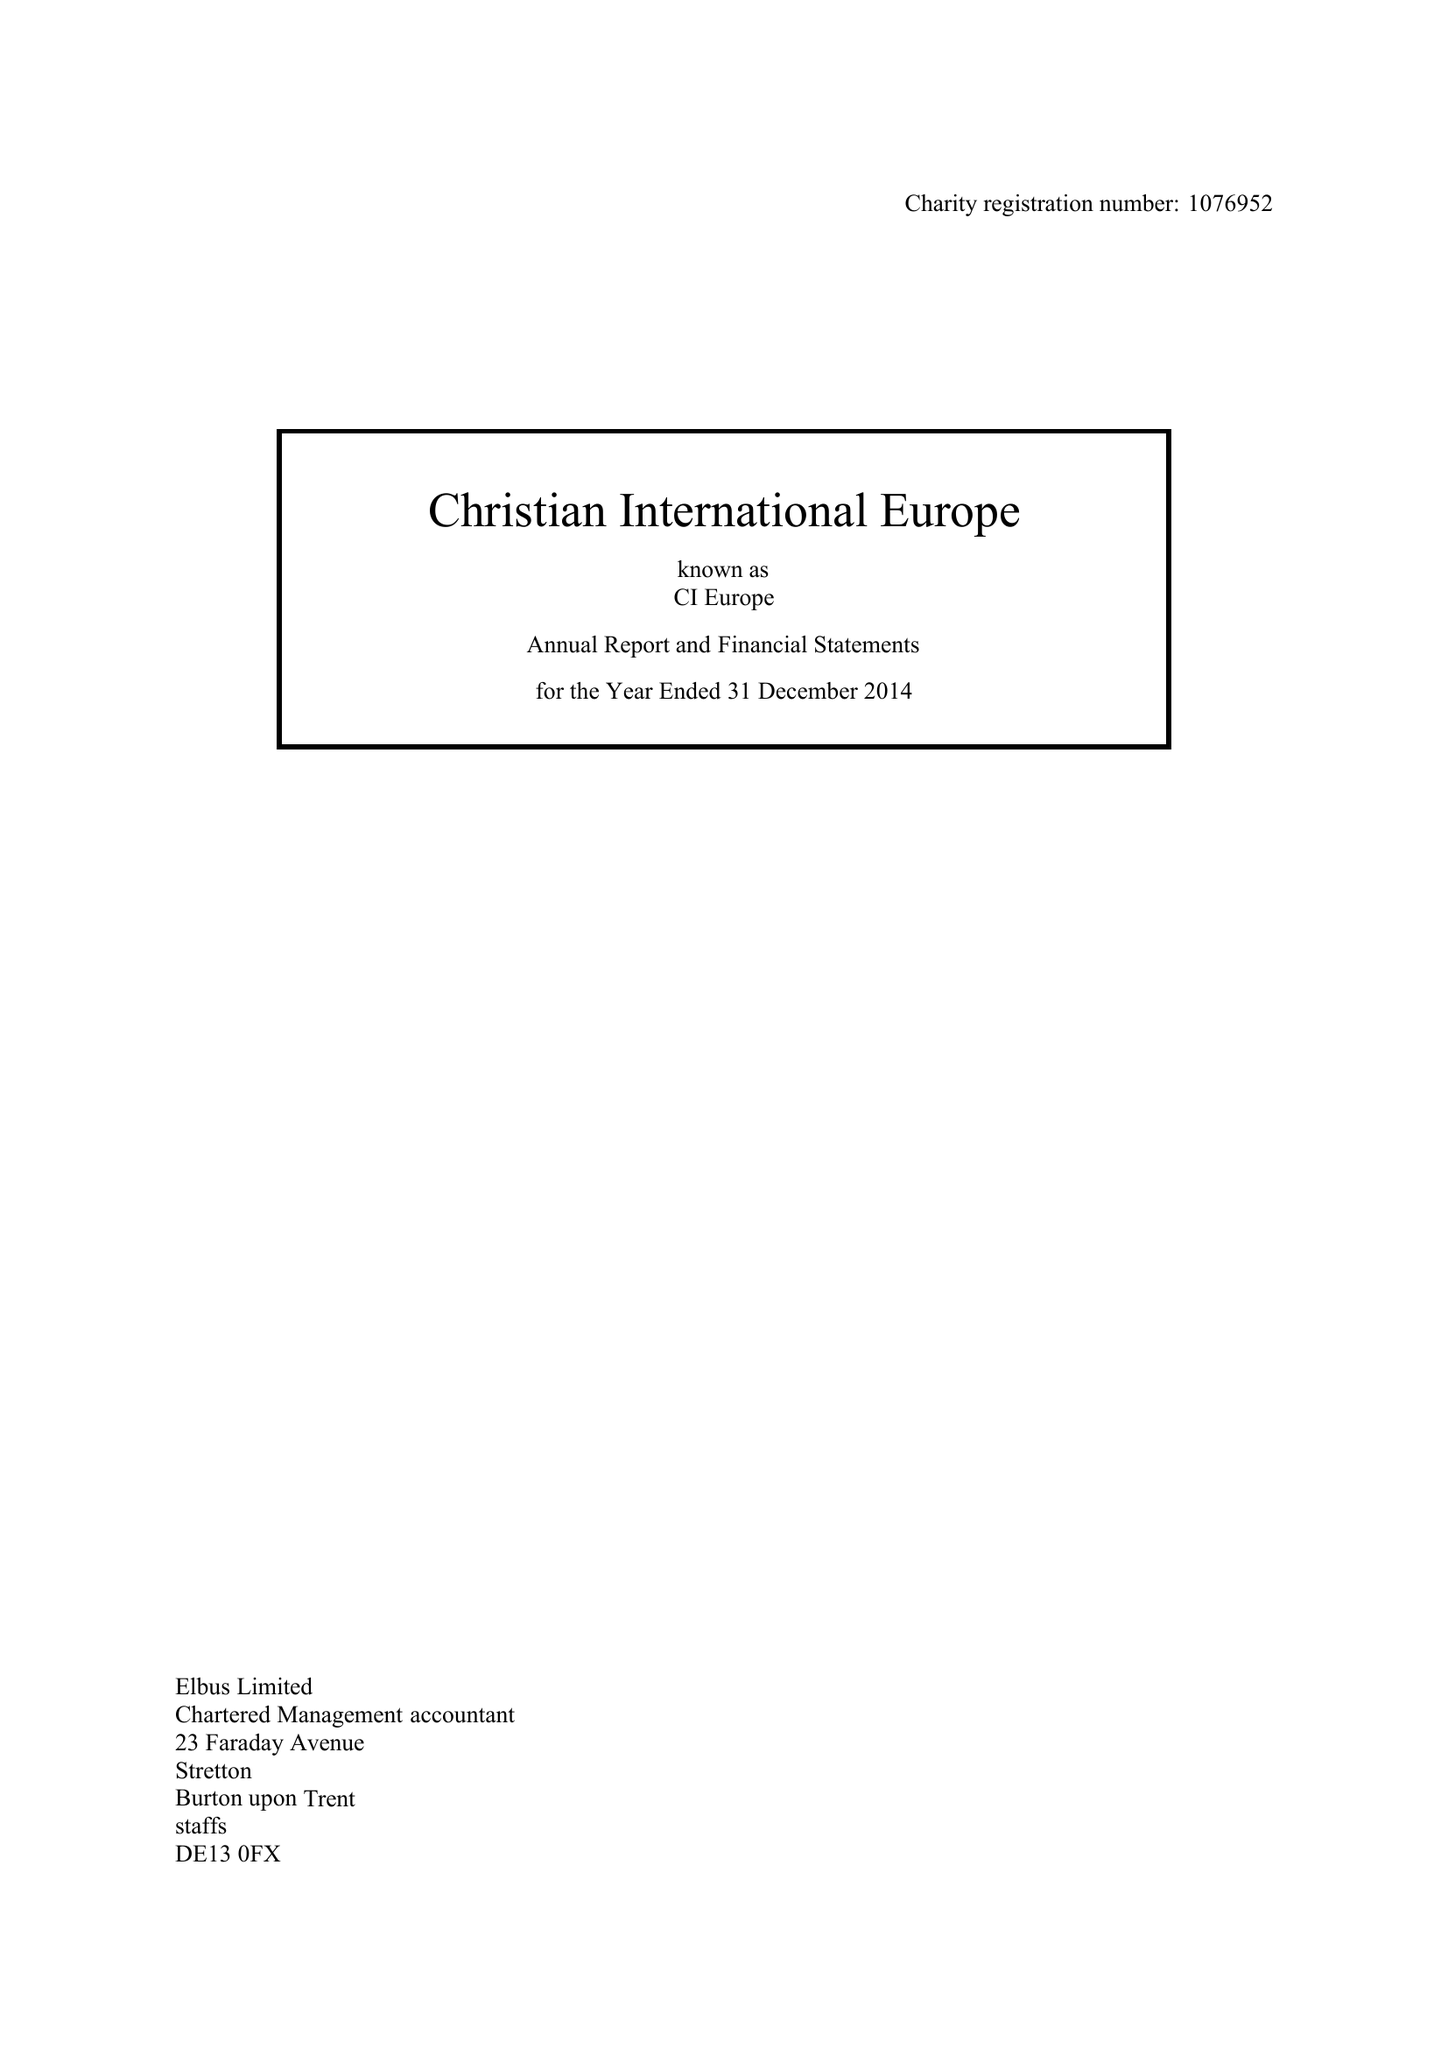What is the value for the address__street_line?
Answer the question using a single word or phrase. PARK STREET 